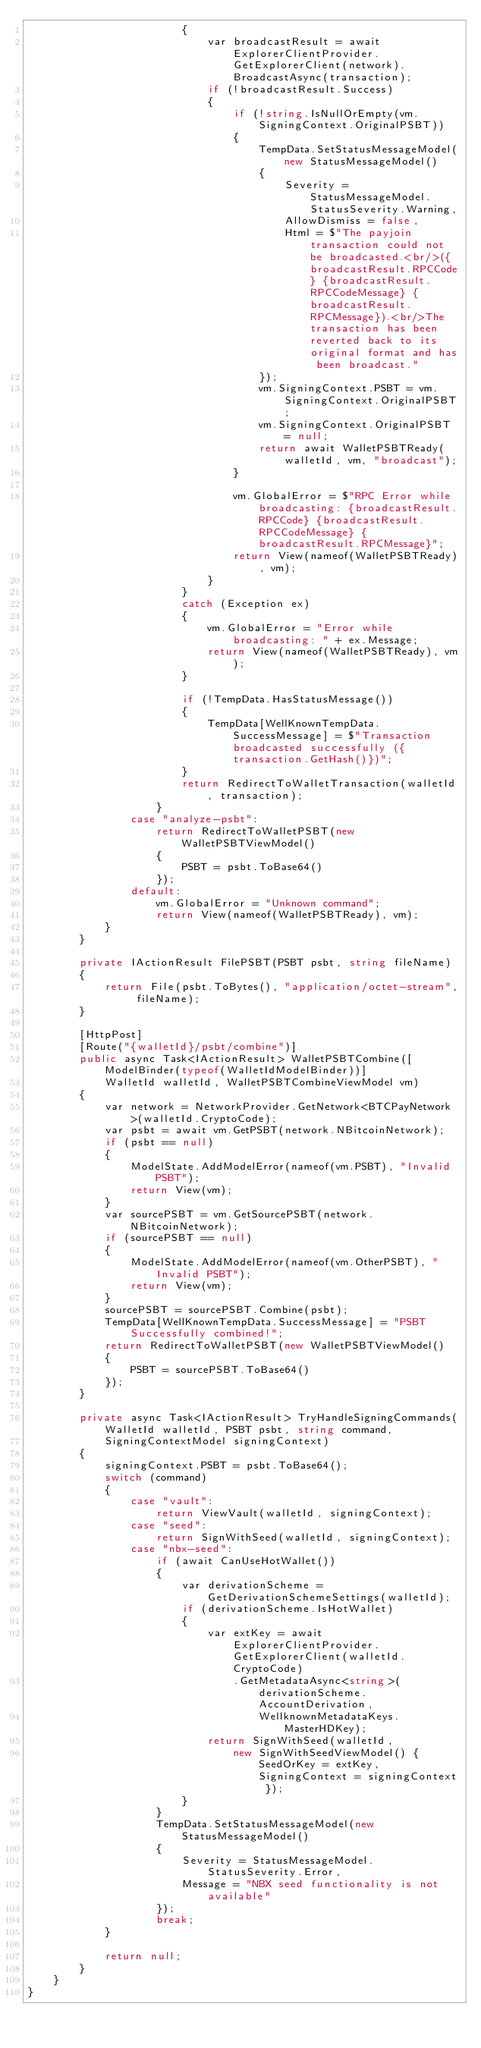<code> <loc_0><loc_0><loc_500><loc_500><_C#_>                        {
                            var broadcastResult = await ExplorerClientProvider.GetExplorerClient(network).BroadcastAsync(transaction);
                            if (!broadcastResult.Success)
                            {
                                if (!string.IsNullOrEmpty(vm.SigningContext.OriginalPSBT))
                                {
                                    TempData.SetStatusMessageModel(new StatusMessageModel()
                                    {
                                        Severity = StatusMessageModel.StatusSeverity.Warning,
                                        AllowDismiss = false,
                                        Html = $"The payjoin transaction could not be broadcasted.<br/>({broadcastResult.RPCCode} {broadcastResult.RPCCodeMessage} {broadcastResult.RPCMessage}).<br/>The transaction has been reverted back to its original format and has been broadcast."
                                    });
                                    vm.SigningContext.PSBT = vm.SigningContext.OriginalPSBT;
                                    vm.SigningContext.OriginalPSBT = null;
                                    return await WalletPSBTReady(walletId, vm, "broadcast");
                                }

                                vm.GlobalError = $"RPC Error while broadcasting: {broadcastResult.RPCCode} {broadcastResult.RPCCodeMessage} {broadcastResult.RPCMessage}";
                                return View(nameof(WalletPSBTReady), vm);
                            }
                        }
                        catch (Exception ex)
                        {
                            vm.GlobalError = "Error while broadcasting: " + ex.Message;
                            return View(nameof(WalletPSBTReady), vm);
                        }

                        if (!TempData.HasStatusMessage())
                        {
                            TempData[WellKnownTempData.SuccessMessage] = $"Transaction broadcasted successfully ({transaction.GetHash()})";
                        }
                        return RedirectToWalletTransaction(walletId, transaction);
                    }
                case "analyze-psbt":
                    return RedirectToWalletPSBT(new WalletPSBTViewModel()
                    {
                        PSBT = psbt.ToBase64()
                    });
                default:
                    vm.GlobalError = "Unknown command";
                    return View(nameof(WalletPSBTReady), vm);
            }
        }

        private IActionResult FilePSBT(PSBT psbt, string fileName)
        {
            return File(psbt.ToBytes(), "application/octet-stream", fileName);
        }

        [HttpPost]
        [Route("{walletId}/psbt/combine")]
        public async Task<IActionResult> WalletPSBTCombine([ModelBinder(typeof(WalletIdModelBinder))]
            WalletId walletId, WalletPSBTCombineViewModel vm)
        {
            var network = NetworkProvider.GetNetwork<BTCPayNetwork>(walletId.CryptoCode);
            var psbt = await vm.GetPSBT(network.NBitcoinNetwork);
            if (psbt == null)
            {
                ModelState.AddModelError(nameof(vm.PSBT), "Invalid PSBT");
                return View(vm);
            }
            var sourcePSBT = vm.GetSourcePSBT(network.NBitcoinNetwork);
            if (sourcePSBT == null)
            {
                ModelState.AddModelError(nameof(vm.OtherPSBT), "Invalid PSBT");
                return View(vm);
            }
            sourcePSBT = sourcePSBT.Combine(psbt);
            TempData[WellKnownTempData.SuccessMessage] = "PSBT Successfully combined!";
            return RedirectToWalletPSBT(new WalletPSBTViewModel()
            {
                PSBT = sourcePSBT.ToBase64()
            });
        }

        private async Task<IActionResult> TryHandleSigningCommands(WalletId walletId, PSBT psbt, string command,
            SigningContextModel signingContext)
        {
            signingContext.PSBT = psbt.ToBase64();
            switch (command)
            {
                case "vault":
                    return ViewVault(walletId, signingContext);
                case "seed":
                    return SignWithSeed(walletId, signingContext);
                case "nbx-seed":
                    if (await CanUseHotWallet())
                    {
                        var derivationScheme = GetDerivationSchemeSettings(walletId);
                        if (derivationScheme.IsHotWallet)
                        {
                            var extKey = await ExplorerClientProvider.GetExplorerClient(walletId.CryptoCode)
                                .GetMetadataAsync<string>(derivationScheme.AccountDerivation,
                                    WellknownMetadataKeys.MasterHDKey);
                            return SignWithSeed(walletId,
                                new SignWithSeedViewModel() { SeedOrKey = extKey, SigningContext = signingContext });
                        }
                    }
                    TempData.SetStatusMessageModel(new StatusMessageModel()
                    {
                        Severity = StatusMessageModel.StatusSeverity.Error,
                        Message = "NBX seed functionality is not available"
                    });
                    break;
            }

            return null;
        }
    }
}
</code> 